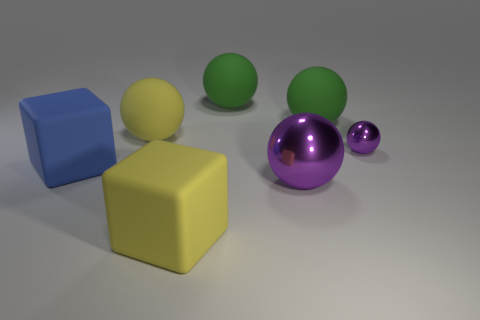What could be the purpose of this image? This image appears to be a 3D rendering that may serve several purposes. It could be a visual asset created to showcase the rendering capabilities of a 3D software program, demonstrating lighting effects, texture application, and color. Additionally, it might serve an educational purpose, such as in a physics context to discuss properties of materials and light, or in an art context to teach about composition and color theory. 